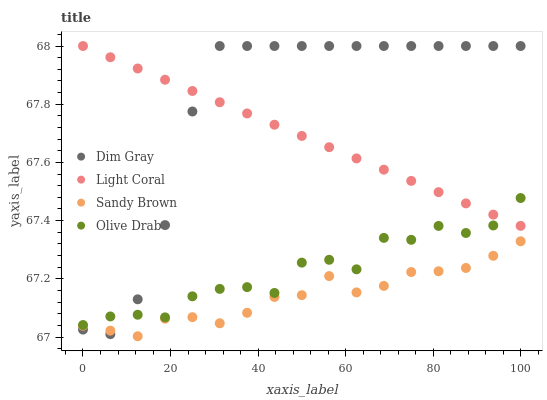Does Sandy Brown have the minimum area under the curve?
Answer yes or no. Yes. Does Dim Gray have the maximum area under the curve?
Answer yes or no. Yes. Does Dim Gray have the minimum area under the curve?
Answer yes or no. No. Does Sandy Brown have the maximum area under the curve?
Answer yes or no. No. Is Light Coral the smoothest?
Answer yes or no. Yes. Is Olive Drab the roughest?
Answer yes or no. Yes. Is Dim Gray the smoothest?
Answer yes or no. No. Is Dim Gray the roughest?
Answer yes or no. No. Does Sandy Brown have the lowest value?
Answer yes or no. Yes. Does Dim Gray have the lowest value?
Answer yes or no. No. Does Dim Gray have the highest value?
Answer yes or no. Yes. Does Sandy Brown have the highest value?
Answer yes or no. No. Is Sandy Brown less than Light Coral?
Answer yes or no. Yes. Is Olive Drab greater than Sandy Brown?
Answer yes or no. Yes. Does Olive Drab intersect Light Coral?
Answer yes or no. Yes. Is Olive Drab less than Light Coral?
Answer yes or no. No. Is Olive Drab greater than Light Coral?
Answer yes or no. No. Does Sandy Brown intersect Light Coral?
Answer yes or no. No. 